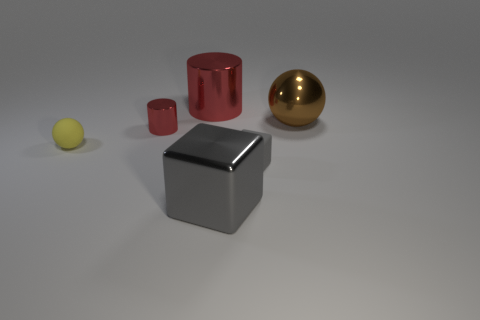How many cubes are the same size as the yellow matte sphere?
Keep it short and to the point. 1. There is a ball on the right side of the yellow matte object; is its size the same as the tiny gray matte block?
Your response must be concise. No. There is a metallic object that is in front of the large brown metal thing and to the right of the large cylinder; what is its shape?
Your response must be concise. Cube. There is a large metallic cube; are there any big gray cubes left of it?
Provide a short and direct response. No. Is there any other thing that is the same shape as the big brown thing?
Make the answer very short. Yes. Do the large red thing and the small yellow thing have the same shape?
Provide a succinct answer. No. Are there the same number of large brown balls that are in front of the small yellow rubber object and red metallic objects that are behind the big red cylinder?
Offer a very short reply. Yes. What number of other things are there of the same material as the large ball
Your response must be concise. 3. How many big things are brown spheres or cubes?
Keep it short and to the point. 2. Are there the same number of tiny yellow objects that are left of the yellow matte object and big metallic spheres?
Provide a succinct answer. No. 